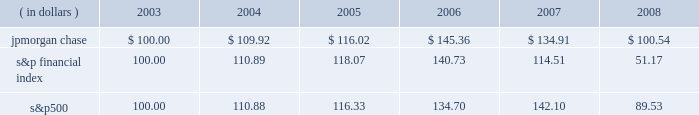Management 2019s discussion and analysis jpmorgan chase & co .
/ 2008 annual report 39 five-year stock performance the table and graph compare the five-year cumulative total return for jpmorgan chase & co .
( 201cjpmorgan chase 201d or the 201cfirm 201d ) common stock with the cumulative return of the s&p 500 stock index and the s&p financial index .
The s&p 500 index is a commonly referenced u.s .
Equity benchmark consisting of leading companies from different economic sectors .
The s&p financial index is an index of 81 financial companies , all of which are within the s&p 500 .
The firm is a component of both industry indices .
The table and graph assumes simultaneous investments of $ 100 on december 31 , 2003 , in jpmorgan chase common stock and in each of the above s&p indices .
The comparison assumes that all dividends are reinvested .
This section of the jpmorgan chase 2019s annual report for the year ended december 31 , 2008 ( 201cannual report 201d ) provides manage- ment 2019s discussion and analysis of the financial condition and results of operations ( 201cmd&a 201d ) of jpmorgan chase .
See the glossary of terms on pages 230 2013233 for definitions of terms used throughout this annual report .
The md&a included in this annual report con- tains statements that are forward-looking within the meaning of the private securities litigation reform act of 1995 .
Such statements are based upon the current beliefs and expectations of jpmorgan december 31 .
December 31 , ( in dollars ) 2003 2004 2005 2006 2007 2008 s&p financial s&p 500jpmorgan chase chase 2019s management and are subject to significant risks and uncer- tainties .
These risks and uncertainties could cause jpmorgan chase 2019s results to differ materially from those set forth in such forward-look- ing statements .
Certain of such risks and uncertainties are described herein ( see forward-looking statements on page 127 of this annual report ) and in the jpmorgan chase annual report on form 10-k for the year ended december 31 , 2008 ( 201c2008 form 10-k 201d ) , in part i , item 1a : risk factors , to which reference is hereby made .
Introduction jpmorgan chase & co. , a financial holding company incorporated under delaware law in 1968 , is a leading global financial services firm and one of the largest banking institutions in the united states of america ( 201cu.s . 201d ) , with $ 2.2 trillion in assets , $ 166.9 billion in stockholders 2019 equity and operations in more than 60 countries as of december 31 , 2008 .
The firm is a leader in investment banking , financial services for consumers and businesses , financial transaction processing and asset management .
Under the j.p .
Morgan and chase brands , the firm serves millions of customers in the u.s .
And many of the world 2019s most prominent corporate , institutional and government clients .
Jpmorgan chase 2019s principal bank subsidiaries are jpmorgan chase bank , national association ( 201cjpmorgan chase bank , n.a . 201d ) , a nation- al banking association with branches in 23 states in the u.s. ; and chase bank usa , national association ( 201cchase bank usa , n.a . 201d ) , a national bank that is the firm 2019s credit card issuing bank .
Jpmorgan chase 2019s principal nonbank subsidiary is j.p .
Morgan securities inc. , the firm 2019s u.s .
Investment banking firm .
Jpmorgan chase 2019s activities are organized , for management reporting purposes , into six business segments , as well as corporate/private equity .
The firm 2019s wholesale businesses comprise the investment bank , commercial banking , treasury & securities services and asset management segments .
The firm 2019s consumer businesses comprise the retail financial services and card services segments .
A description of the firm 2019s business segments , and the products and services they pro- vide to their respective client bases , follows .
Investment bank j.p .
Morgan is one of the world 2019s leading investment banks , with deep client relationships and broad product capabilities .
The investment bank 2019s clients are corporations , financial institutions , governments and institutional investors .
The firm offers a full range of investment banking products and services in all major capital markets , including advising on corporate strategy and structure , cap- ital raising in equity and debt markets , sophisticated risk manage- ment , market-making in cash securities and derivative instruments , prime brokerage and research .
The investment bank ( 201cib 201d ) also selectively commits the firm 2019s own capital to principal investing and trading activities .
Retail financial services retail financial services ( 201crfs 201d ) , which includes the retail banking and consumer lending reporting segments , serves consumers and businesses through personal service at bank branches and through atms , online banking and telephone banking as well as through auto dealerships and school financial aid offices .
Customers can use more than 5400 bank branches ( third-largest nationally ) and 14500 atms ( second-largest nationally ) as well as online and mobile bank- ing around the clock .
More than 21400 branch salespeople assist .
In the retail segment , what is the average number of salespeople in each branch? 
Computations: (21400 / 5400)
Answer: 3.96296. 